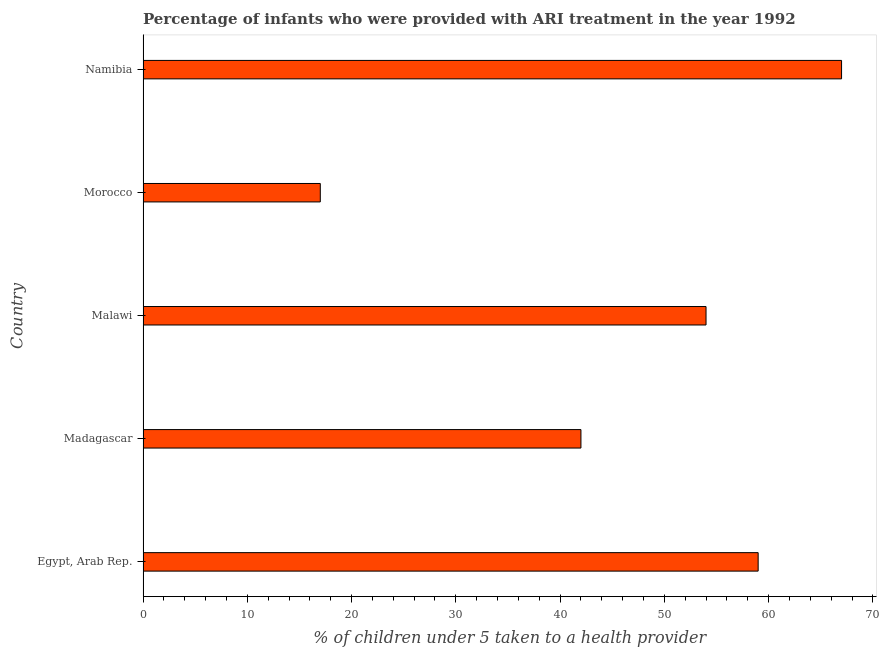Does the graph contain any zero values?
Provide a succinct answer. No. Does the graph contain grids?
Your answer should be compact. No. What is the title of the graph?
Provide a succinct answer. Percentage of infants who were provided with ARI treatment in the year 1992. What is the label or title of the X-axis?
Your answer should be compact. % of children under 5 taken to a health provider. What is the percentage of children who were provided with ari treatment in Malawi?
Give a very brief answer. 54. Across all countries, what is the maximum percentage of children who were provided with ari treatment?
Provide a succinct answer. 67. Across all countries, what is the minimum percentage of children who were provided with ari treatment?
Your answer should be very brief. 17. In which country was the percentage of children who were provided with ari treatment maximum?
Ensure brevity in your answer.  Namibia. In which country was the percentage of children who were provided with ari treatment minimum?
Give a very brief answer. Morocco. What is the sum of the percentage of children who were provided with ari treatment?
Ensure brevity in your answer.  239. What is the difference between the percentage of children who were provided with ari treatment in Morocco and Namibia?
Make the answer very short. -50. What is the average percentage of children who were provided with ari treatment per country?
Your response must be concise. 47. What is the ratio of the percentage of children who were provided with ari treatment in Egypt, Arab Rep. to that in Madagascar?
Ensure brevity in your answer.  1.41. Is the percentage of children who were provided with ari treatment in Egypt, Arab Rep. less than that in Madagascar?
Offer a terse response. No. What is the difference between the highest and the lowest percentage of children who were provided with ari treatment?
Your response must be concise. 50. Are all the bars in the graph horizontal?
Provide a succinct answer. Yes. What is the difference between two consecutive major ticks on the X-axis?
Give a very brief answer. 10. Are the values on the major ticks of X-axis written in scientific E-notation?
Give a very brief answer. No. What is the % of children under 5 taken to a health provider in Egypt, Arab Rep.?
Provide a succinct answer. 59. What is the % of children under 5 taken to a health provider of Madagascar?
Your answer should be very brief. 42. What is the difference between the % of children under 5 taken to a health provider in Egypt, Arab Rep. and Madagascar?
Your answer should be compact. 17. What is the difference between the % of children under 5 taken to a health provider in Egypt, Arab Rep. and Malawi?
Give a very brief answer. 5. What is the difference between the % of children under 5 taken to a health provider in Madagascar and Malawi?
Your answer should be very brief. -12. What is the difference between the % of children under 5 taken to a health provider in Madagascar and Morocco?
Offer a terse response. 25. What is the difference between the % of children under 5 taken to a health provider in Malawi and Morocco?
Give a very brief answer. 37. What is the difference between the % of children under 5 taken to a health provider in Malawi and Namibia?
Ensure brevity in your answer.  -13. What is the difference between the % of children under 5 taken to a health provider in Morocco and Namibia?
Your response must be concise. -50. What is the ratio of the % of children under 5 taken to a health provider in Egypt, Arab Rep. to that in Madagascar?
Keep it short and to the point. 1.41. What is the ratio of the % of children under 5 taken to a health provider in Egypt, Arab Rep. to that in Malawi?
Ensure brevity in your answer.  1.09. What is the ratio of the % of children under 5 taken to a health provider in Egypt, Arab Rep. to that in Morocco?
Make the answer very short. 3.47. What is the ratio of the % of children under 5 taken to a health provider in Egypt, Arab Rep. to that in Namibia?
Your answer should be compact. 0.88. What is the ratio of the % of children under 5 taken to a health provider in Madagascar to that in Malawi?
Offer a very short reply. 0.78. What is the ratio of the % of children under 5 taken to a health provider in Madagascar to that in Morocco?
Make the answer very short. 2.47. What is the ratio of the % of children under 5 taken to a health provider in Madagascar to that in Namibia?
Make the answer very short. 0.63. What is the ratio of the % of children under 5 taken to a health provider in Malawi to that in Morocco?
Provide a short and direct response. 3.18. What is the ratio of the % of children under 5 taken to a health provider in Malawi to that in Namibia?
Give a very brief answer. 0.81. What is the ratio of the % of children under 5 taken to a health provider in Morocco to that in Namibia?
Offer a very short reply. 0.25. 